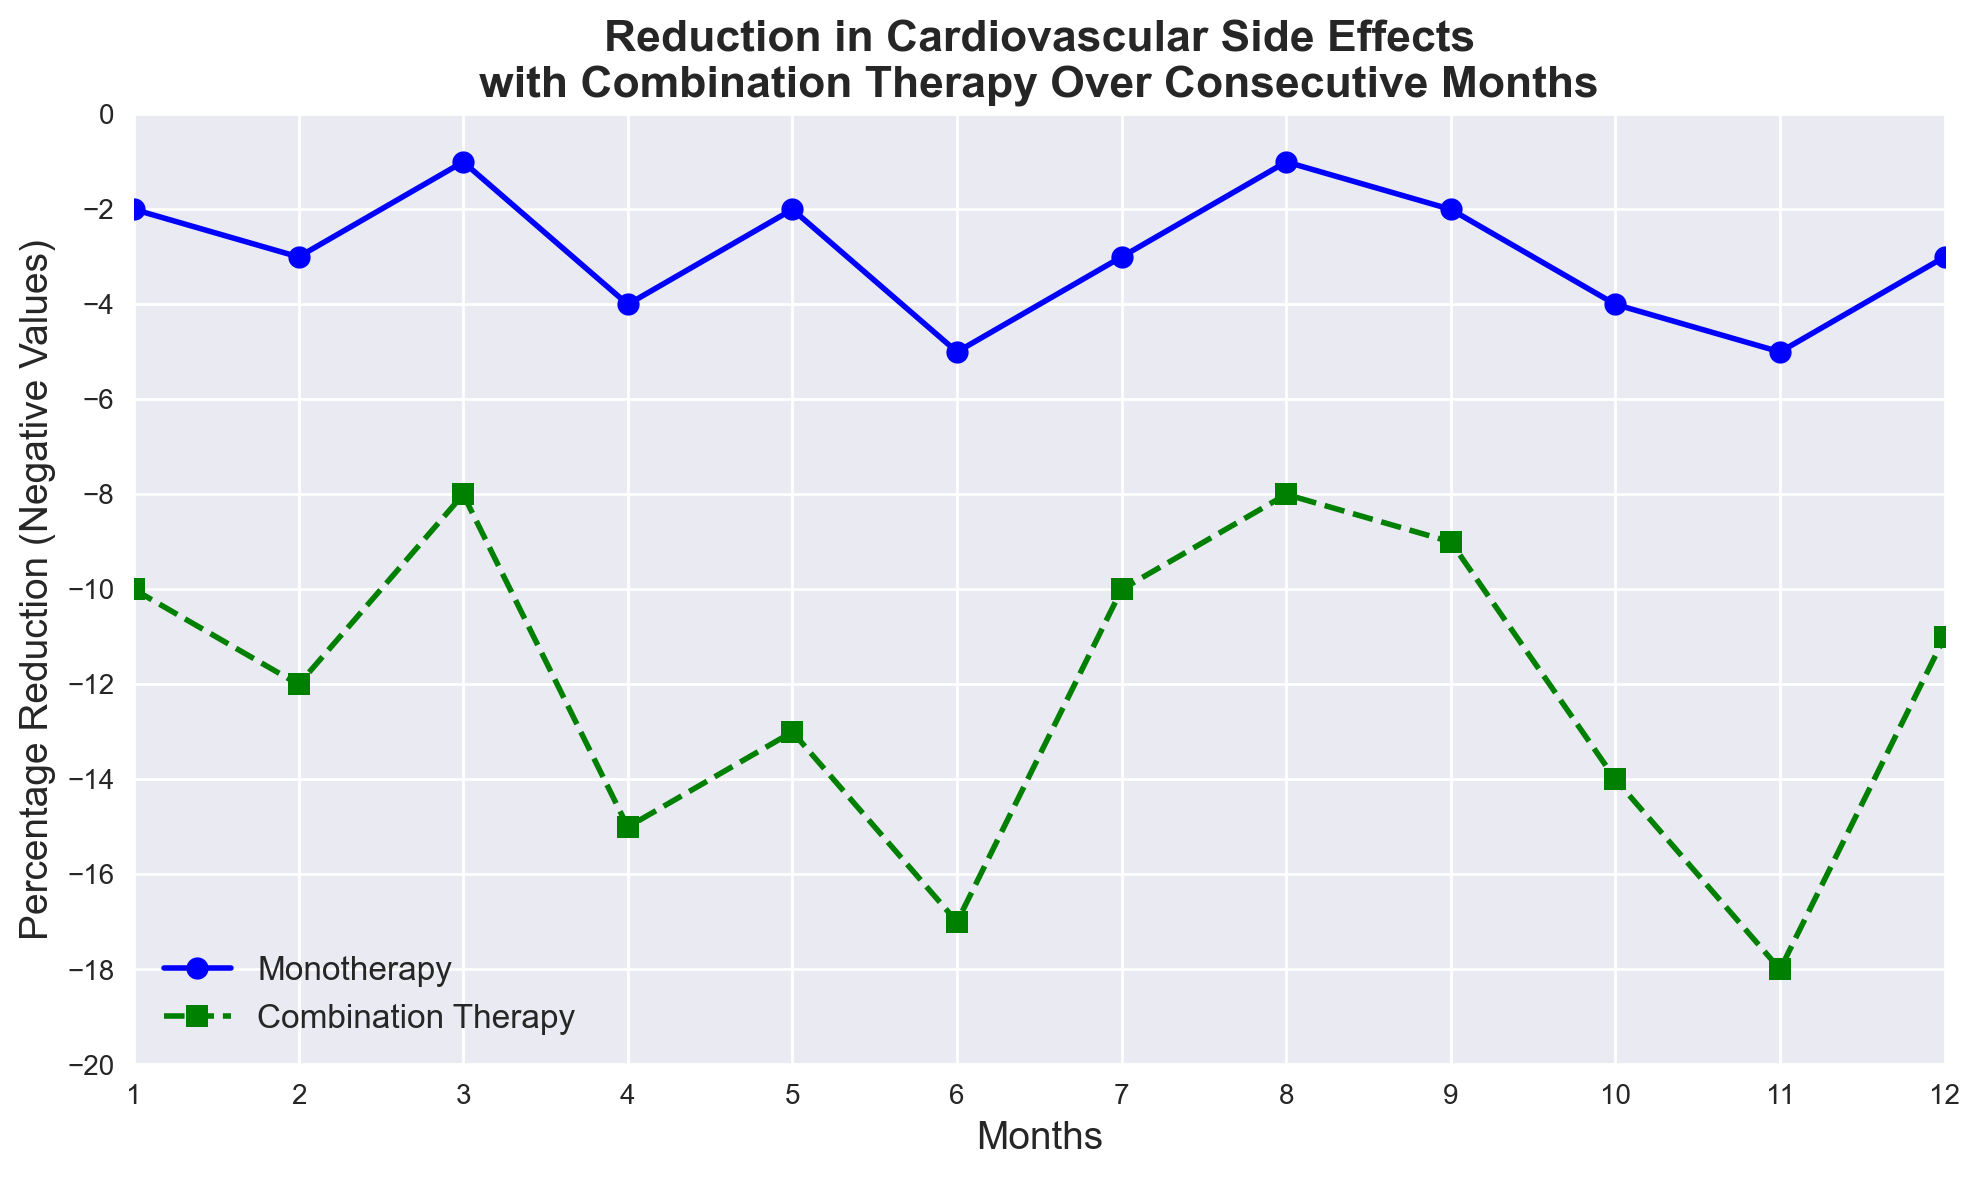Which month shows the greatest reduction in cardiovascular side effects for Monotherapy? To find the month with the greatest reduction in cardiovascular side effects for Monotherapy, look for the lowest value in the Monotherapy line. This occurs at month 6 with a value of -5.
Answer: Month 6 Which therapy shows a greater reduction in cardiovascular side effects overall? To determine which therapy shows a greater reduction overall, observe the y-axis values. The Combination Therapy line consistently has lower values than the Monotherapy line, indicating a greater overall reduction.
Answer: Combination Therapy What's the average reduction in cardiovascular side effects for Monotherapy over the 12 months? Calculate the average reduction by summing all the monthly reductions for Monotherapy and then dividing by 12. (-2 + -3 + -1 + -4 + -2 + -5 + -3 + -1 + -2 + -4 + -5 + -3) / 12 = -35 / 12 ≈ -2.92
Answer: -2.92 What's the difference in the reduction of cardiovascular side effects between Combination Therapy and Monotherapy in month 4? Identify the values for month 4: Monotherapy is -4, and Combination Therapy is -15. The difference is -15 - (-4) = -11.
Answer: -11 How does the reduction in cardiovascular side effects for Combination Therapy change from month 6 to month 12? For Combination Therapy, the value in month 6 is -17, and in month 12 it is -11. The change is -11 - (-17) = 6, indicating an increase in side effects (or less reduction) of 6 percentage points.
Answer: Increased by 6 What is the median reduction in cardiovascular side effects for Combination Therapy? First, list the Combination Therapy values in order: -18, -17, -15, -14, -13, -12, -11, -10, -10, -9, -8, -8. The median is the average of the 6th and 7th values: (-12 + -11) / 2 = -11.5.
Answer: -11.5 In which month is the reduction in cardiovascular side effects equal for both therapies? Check the plotted values month by month to find where the values are equal. There is no month where the values are exactly equal.
Answer: None Which month shows the smallest difference in reduction between the two therapies? Calculate the differences for each month and find the smallest one: Month 1: 8, Month 2: 9, Month 3: 7, Month 4: 11, Month 5: 11, Month 6: 12, Month 7: 7, Month 8: 7, Month 9: 7, Month 10: 10, Month 11: 13, Month 12: 8. The smallest difference is 7, occurring in months 3, 7, 8, and 9.
Answer: Months 3, 7, 8, and 9 By how much does the reduction in cardiovascular side effects differ between the two therapies over the entire year? Calculate the total reduction of each therapy and find the difference. Monotherapy total: -35, Combination Therapy total: -137. The difference is -137 - (-35) = -102.
Answer: -102 What trend can be observed for Monotherapy from months 1 to 12? Track the pattern of Monotherapy's reductions: The values fluctuate but generally hover between -1 and -5 without a clear increasing or decreasing trend.
Answer: Fluctuating 